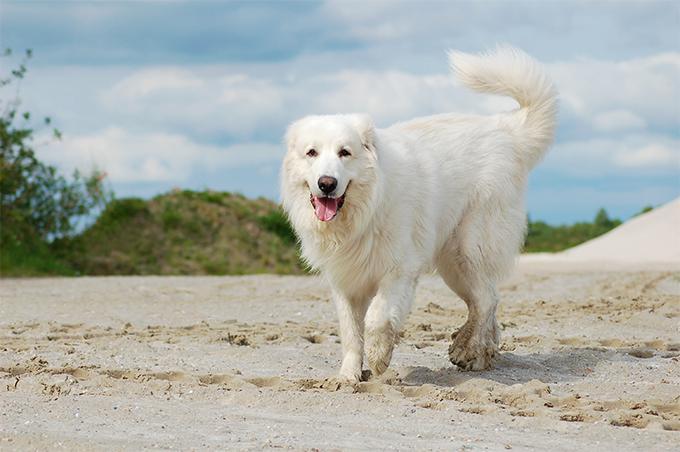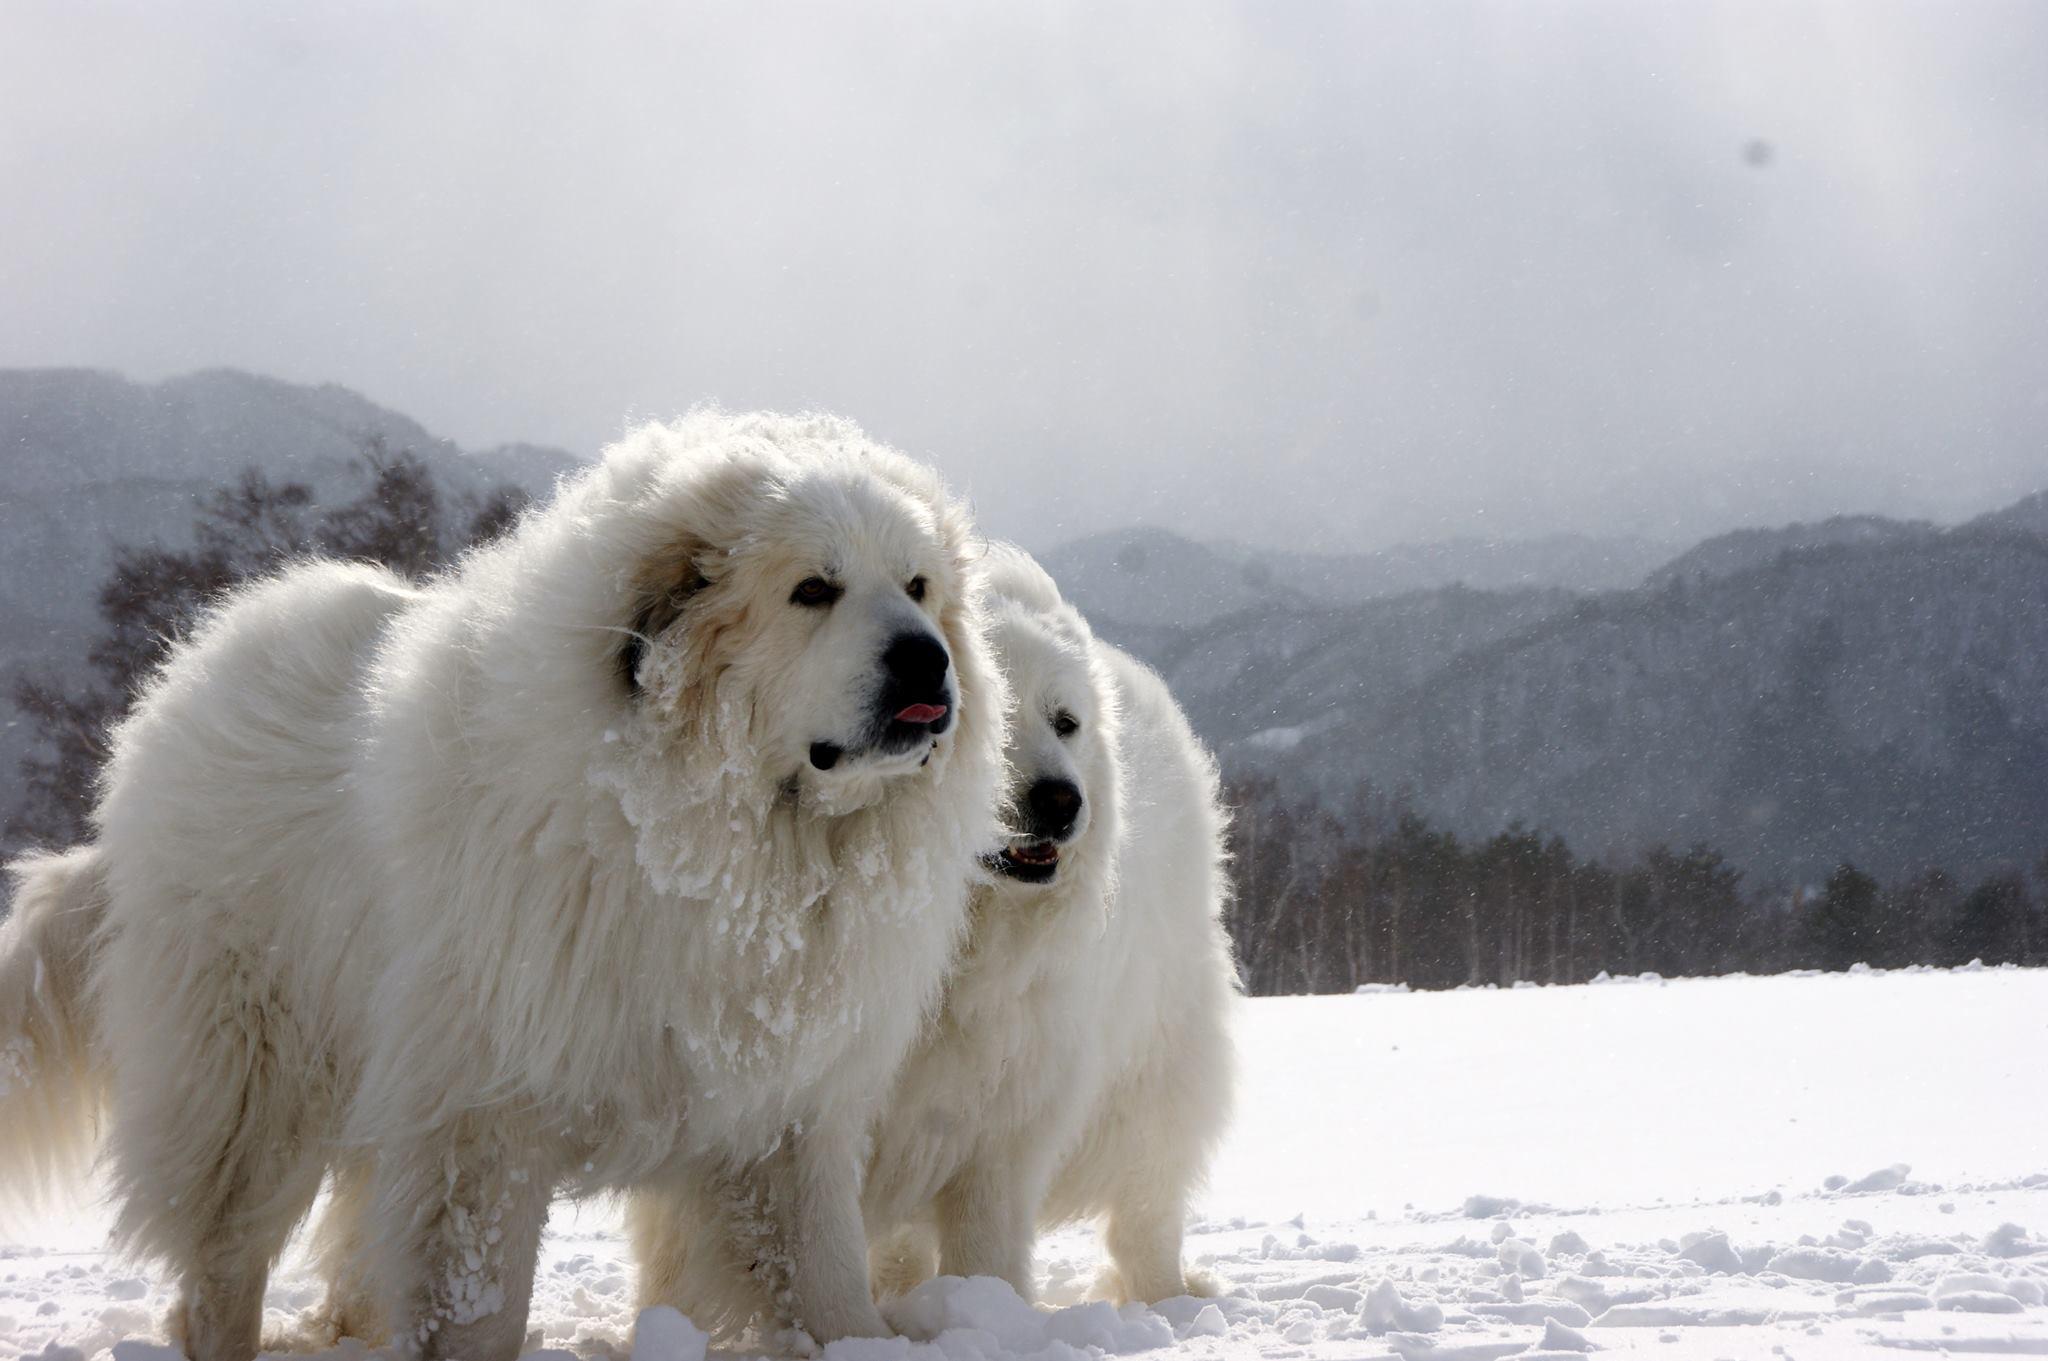The first image is the image on the left, the second image is the image on the right. Examine the images to the left and right. Is the description "The right image has two dogs near each other." accurate? Answer yes or no. Yes. 